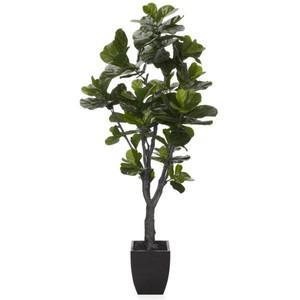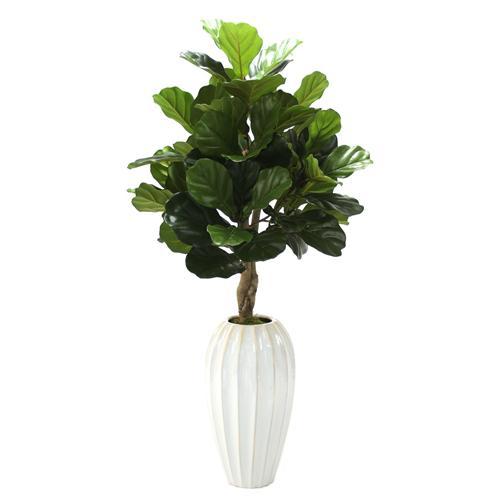The first image is the image on the left, the second image is the image on the right. Examine the images to the left and right. Is the description "One vase is tall, opaque and solid-colored with a ribbed surface, and the other vase is shorter and black in color." accurate? Answer yes or no. Yes. The first image is the image on the left, the second image is the image on the right. Evaluate the accuracy of this statement regarding the images: "At least one vase is clear glass.". Is it true? Answer yes or no. No. 